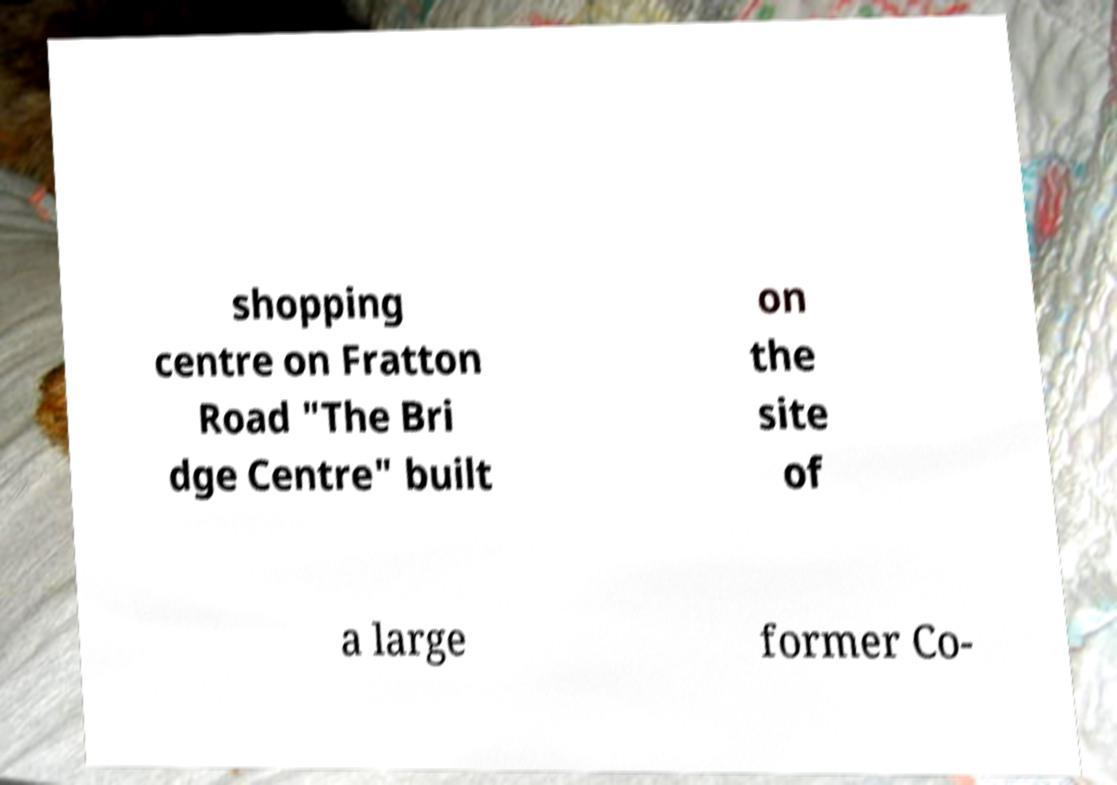There's text embedded in this image that I need extracted. Can you transcribe it verbatim? shopping centre on Fratton Road "The Bri dge Centre" built on the site of a large former Co- 